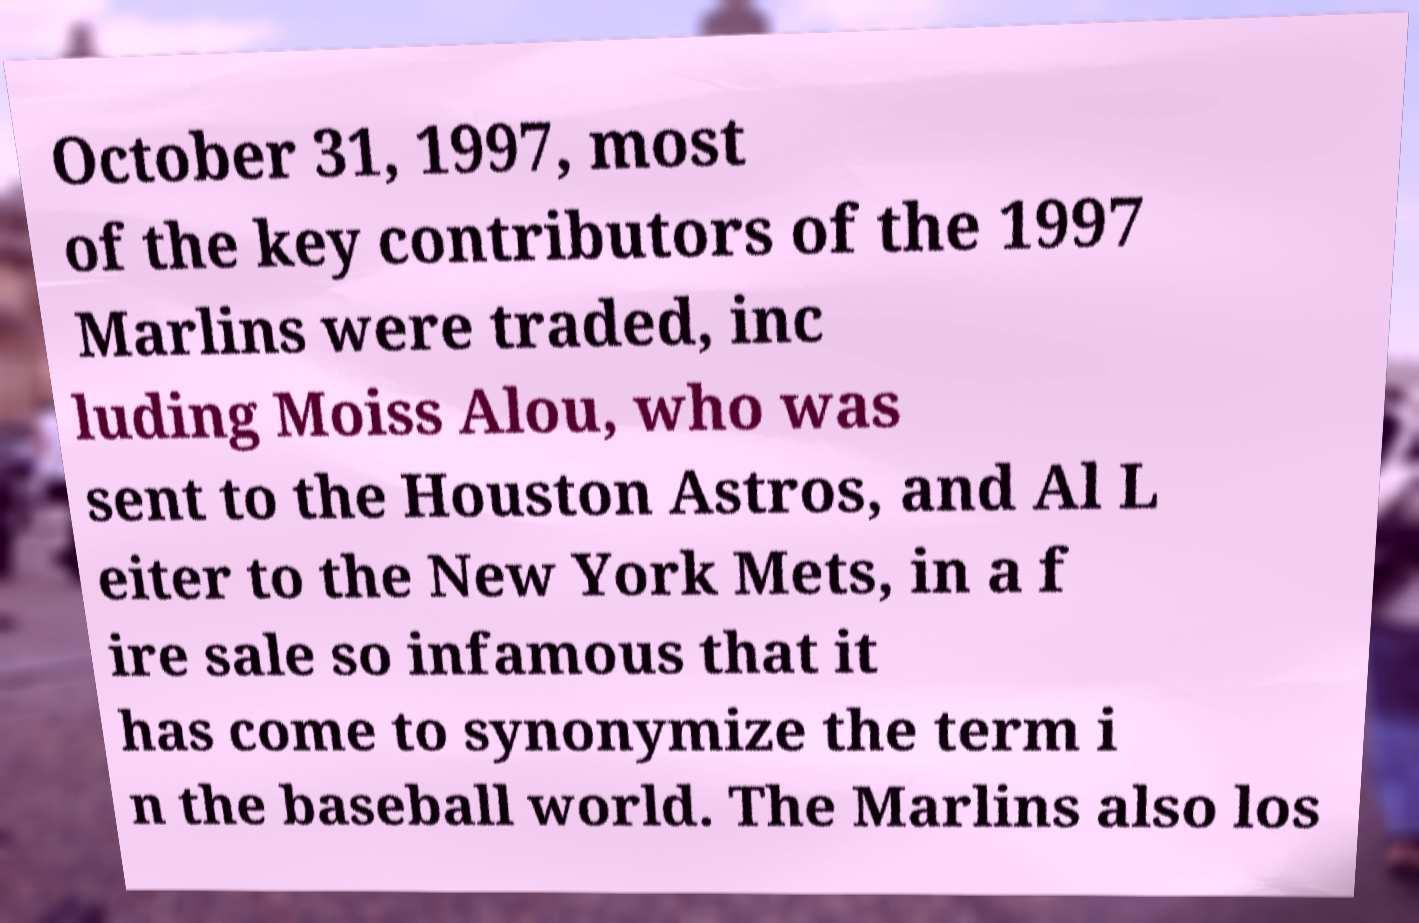I need the written content from this picture converted into text. Can you do that? October 31, 1997, most of the key contributors of the 1997 Marlins were traded, inc luding Moiss Alou, who was sent to the Houston Astros, and Al L eiter to the New York Mets, in a f ire sale so infamous that it has come to synonymize the term i n the baseball world. The Marlins also los 